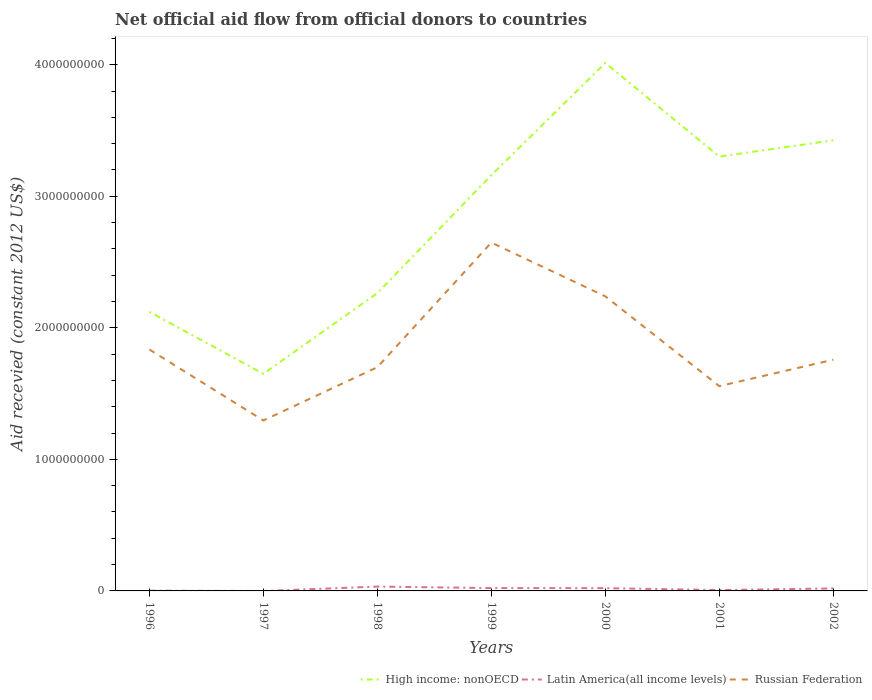Does the line corresponding to Russian Federation intersect with the line corresponding to Latin America(all income levels)?
Offer a very short reply. No. What is the total total aid received in High income: nonOECD in the graph?
Give a very brief answer. -1.30e+09. What is the difference between the highest and the second highest total aid received in Russian Federation?
Offer a terse response. 1.35e+09. How many lines are there?
Ensure brevity in your answer.  3. What is the difference between two consecutive major ticks on the Y-axis?
Make the answer very short. 1.00e+09. Are the values on the major ticks of Y-axis written in scientific E-notation?
Offer a terse response. No. Does the graph contain any zero values?
Make the answer very short. Yes. Does the graph contain grids?
Your answer should be compact. No. Where does the legend appear in the graph?
Offer a very short reply. Bottom right. How are the legend labels stacked?
Provide a short and direct response. Horizontal. What is the title of the graph?
Your answer should be compact. Net official aid flow from official donors to countries. What is the label or title of the Y-axis?
Offer a very short reply. Aid recevied (constant 2012 US$). What is the Aid recevied (constant 2012 US$) in High income: nonOECD in 1996?
Your answer should be compact. 2.12e+09. What is the Aid recevied (constant 2012 US$) of Latin America(all income levels) in 1996?
Your response must be concise. 2.04e+06. What is the Aid recevied (constant 2012 US$) of Russian Federation in 1996?
Give a very brief answer. 1.84e+09. What is the Aid recevied (constant 2012 US$) in High income: nonOECD in 1997?
Make the answer very short. 1.65e+09. What is the Aid recevied (constant 2012 US$) of Russian Federation in 1997?
Offer a very short reply. 1.30e+09. What is the Aid recevied (constant 2012 US$) in High income: nonOECD in 1998?
Provide a succinct answer. 2.26e+09. What is the Aid recevied (constant 2012 US$) in Latin America(all income levels) in 1998?
Ensure brevity in your answer.  3.30e+07. What is the Aid recevied (constant 2012 US$) in Russian Federation in 1998?
Keep it short and to the point. 1.70e+09. What is the Aid recevied (constant 2012 US$) in High income: nonOECD in 1999?
Make the answer very short. 3.16e+09. What is the Aid recevied (constant 2012 US$) in Latin America(all income levels) in 1999?
Offer a terse response. 2.15e+07. What is the Aid recevied (constant 2012 US$) in Russian Federation in 1999?
Your answer should be compact. 2.65e+09. What is the Aid recevied (constant 2012 US$) of High income: nonOECD in 2000?
Make the answer very short. 4.01e+09. What is the Aid recevied (constant 2012 US$) of Latin America(all income levels) in 2000?
Provide a succinct answer. 2.10e+07. What is the Aid recevied (constant 2012 US$) of Russian Federation in 2000?
Provide a short and direct response. 2.24e+09. What is the Aid recevied (constant 2012 US$) in High income: nonOECD in 2001?
Your response must be concise. 3.30e+09. What is the Aid recevied (constant 2012 US$) in Latin America(all income levels) in 2001?
Provide a succinct answer. 6.75e+06. What is the Aid recevied (constant 2012 US$) of Russian Federation in 2001?
Your answer should be very brief. 1.56e+09. What is the Aid recevied (constant 2012 US$) of High income: nonOECD in 2002?
Make the answer very short. 3.43e+09. What is the Aid recevied (constant 2012 US$) of Latin America(all income levels) in 2002?
Your answer should be very brief. 1.90e+07. What is the Aid recevied (constant 2012 US$) in Russian Federation in 2002?
Your answer should be compact. 1.76e+09. Across all years, what is the maximum Aid recevied (constant 2012 US$) in High income: nonOECD?
Keep it short and to the point. 4.01e+09. Across all years, what is the maximum Aid recevied (constant 2012 US$) of Latin America(all income levels)?
Keep it short and to the point. 3.30e+07. Across all years, what is the maximum Aid recevied (constant 2012 US$) of Russian Federation?
Ensure brevity in your answer.  2.65e+09. Across all years, what is the minimum Aid recevied (constant 2012 US$) in High income: nonOECD?
Make the answer very short. 1.65e+09. Across all years, what is the minimum Aid recevied (constant 2012 US$) of Russian Federation?
Offer a terse response. 1.30e+09. What is the total Aid recevied (constant 2012 US$) of High income: nonOECD in the graph?
Make the answer very short. 1.99e+1. What is the total Aid recevied (constant 2012 US$) of Latin America(all income levels) in the graph?
Give a very brief answer. 1.03e+08. What is the total Aid recevied (constant 2012 US$) in Russian Federation in the graph?
Provide a short and direct response. 1.30e+1. What is the difference between the Aid recevied (constant 2012 US$) in High income: nonOECD in 1996 and that in 1997?
Your answer should be compact. 4.71e+08. What is the difference between the Aid recevied (constant 2012 US$) in Russian Federation in 1996 and that in 1997?
Offer a terse response. 5.39e+08. What is the difference between the Aid recevied (constant 2012 US$) of High income: nonOECD in 1996 and that in 1998?
Give a very brief answer. -1.43e+08. What is the difference between the Aid recevied (constant 2012 US$) of Latin America(all income levels) in 1996 and that in 1998?
Keep it short and to the point. -3.10e+07. What is the difference between the Aid recevied (constant 2012 US$) in Russian Federation in 1996 and that in 1998?
Your answer should be very brief. 1.34e+08. What is the difference between the Aid recevied (constant 2012 US$) of High income: nonOECD in 1996 and that in 1999?
Keep it short and to the point. -1.04e+09. What is the difference between the Aid recevied (constant 2012 US$) in Latin America(all income levels) in 1996 and that in 1999?
Keep it short and to the point. -1.95e+07. What is the difference between the Aid recevied (constant 2012 US$) of Russian Federation in 1996 and that in 1999?
Ensure brevity in your answer.  -8.13e+08. What is the difference between the Aid recevied (constant 2012 US$) of High income: nonOECD in 1996 and that in 2000?
Give a very brief answer. -1.89e+09. What is the difference between the Aid recevied (constant 2012 US$) in Latin America(all income levels) in 1996 and that in 2000?
Provide a succinct answer. -1.90e+07. What is the difference between the Aid recevied (constant 2012 US$) of Russian Federation in 1996 and that in 2000?
Provide a succinct answer. -4.04e+08. What is the difference between the Aid recevied (constant 2012 US$) of High income: nonOECD in 1996 and that in 2001?
Your response must be concise. -1.18e+09. What is the difference between the Aid recevied (constant 2012 US$) in Latin America(all income levels) in 1996 and that in 2001?
Give a very brief answer. -4.71e+06. What is the difference between the Aid recevied (constant 2012 US$) of Russian Federation in 1996 and that in 2001?
Your answer should be compact. 2.78e+08. What is the difference between the Aid recevied (constant 2012 US$) of High income: nonOECD in 1996 and that in 2002?
Provide a short and direct response. -1.30e+09. What is the difference between the Aid recevied (constant 2012 US$) in Latin America(all income levels) in 1996 and that in 2002?
Your answer should be compact. -1.70e+07. What is the difference between the Aid recevied (constant 2012 US$) of Russian Federation in 1996 and that in 2002?
Ensure brevity in your answer.  7.76e+07. What is the difference between the Aid recevied (constant 2012 US$) in High income: nonOECD in 1997 and that in 1998?
Offer a terse response. -6.13e+08. What is the difference between the Aid recevied (constant 2012 US$) in Russian Federation in 1997 and that in 1998?
Offer a very short reply. -4.05e+08. What is the difference between the Aid recevied (constant 2012 US$) of High income: nonOECD in 1997 and that in 1999?
Provide a short and direct response. -1.51e+09. What is the difference between the Aid recevied (constant 2012 US$) in Russian Federation in 1997 and that in 1999?
Give a very brief answer. -1.35e+09. What is the difference between the Aid recevied (constant 2012 US$) in High income: nonOECD in 1997 and that in 2000?
Provide a short and direct response. -2.36e+09. What is the difference between the Aid recevied (constant 2012 US$) in Russian Federation in 1997 and that in 2000?
Your answer should be very brief. -9.44e+08. What is the difference between the Aid recevied (constant 2012 US$) of High income: nonOECD in 1997 and that in 2001?
Give a very brief answer. -1.65e+09. What is the difference between the Aid recevied (constant 2012 US$) of Russian Federation in 1997 and that in 2001?
Provide a succinct answer. -2.61e+08. What is the difference between the Aid recevied (constant 2012 US$) in High income: nonOECD in 1997 and that in 2002?
Your answer should be compact. -1.78e+09. What is the difference between the Aid recevied (constant 2012 US$) in Russian Federation in 1997 and that in 2002?
Give a very brief answer. -4.62e+08. What is the difference between the Aid recevied (constant 2012 US$) of High income: nonOECD in 1998 and that in 1999?
Give a very brief answer. -8.97e+08. What is the difference between the Aid recevied (constant 2012 US$) in Latin America(all income levels) in 1998 and that in 1999?
Make the answer very short. 1.15e+07. What is the difference between the Aid recevied (constant 2012 US$) in Russian Federation in 1998 and that in 1999?
Ensure brevity in your answer.  -9.47e+08. What is the difference between the Aid recevied (constant 2012 US$) in High income: nonOECD in 1998 and that in 2000?
Make the answer very short. -1.75e+09. What is the difference between the Aid recevied (constant 2012 US$) in Latin America(all income levels) in 1998 and that in 2000?
Ensure brevity in your answer.  1.20e+07. What is the difference between the Aid recevied (constant 2012 US$) of Russian Federation in 1998 and that in 2000?
Make the answer very short. -5.38e+08. What is the difference between the Aid recevied (constant 2012 US$) of High income: nonOECD in 1998 and that in 2001?
Your answer should be very brief. -1.04e+09. What is the difference between the Aid recevied (constant 2012 US$) of Latin America(all income levels) in 1998 and that in 2001?
Your answer should be compact. 2.63e+07. What is the difference between the Aid recevied (constant 2012 US$) of Russian Federation in 1998 and that in 2001?
Provide a succinct answer. 1.44e+08. What is the difference between the Aid recevied (constant 2012 US$) of High income: nonOECD in 1998 and that in 2002?
Give a very brief answer. -1.16e+09. What is the difference between the Aid recevied (constant 2012 US$) in Latin America(all income levels) in 1998 and that in 2002?
Make the answer very short. 1.40e+07. What is the difference between the Aid recevied (constant 2012 US$) in Russian Federation in 1998 and that in 2002?
Make the answer very short. -5.68e+07. What is the difference between the Aid recevied (constant 2012 US$) of High income: nonOECD in 1999 and that in 2000?
Ensure brevity in your answer.  -8.53e+08. What is the difference between the Aid recevied (constant 2012 US$) in Russian Federation in 1999 and that in 2000?
Keep it short and to the point. 4.09e+08. What is the difference between the Aid recevied (constant 2012 US$) of High income: nonOECD in 1999 and that in 2001?
Ensure brevity in your answer.  -1.41e+08. What is the difference between the Aid recevied (constant 2012 US$) of Latin America(all income levels) in 1999 and that in 2001?
Offer a very short reply. 1.48e+07. What is the difference between the Aid recevied (constant 2012 US$) of Russian Federation in 1999 and that in 2001?
Ensure brevity in your answer.  1.09e+09. What is the difference between the Aid recevied (constant 2012 US$) in High income: nonOECD in 1999 and that in 2002?
Your response must be concise. -2.65e+08. What is the difference between the Aid recevied (constant 2012 US$) in Latin America(all income levels) in 1999 and that in 2002?
Your answer should be very brief. 2.47e+06. What is the difference between the Aid recevied (constant 2012 US$) of Russian Federation in 1999 and that in 2002?
Offer a terse response. 8.90e+08. What is the difference between the Aid recevied (constant 2012 US$) in High income: nonOECD in 2000 and that in 2001?
Ensure brevity in your answer.  7.12e+08. What is the difference between the Aid recevied (constant 2012 US$) of Latin America(all income levels) in 2000 and that in 2001?
Offer a very short reply. 1.43e+07. What is the difference between the Aid recevied (constant 2012 US$) of Russian Federation in 2000 and that in 2001?
Your answer should be very brief. 6.83e+08. What is the difference between the Aid recevied (constant 2012 US$) in High income: nonOECD in 2000 and that in 2002?
Give a very brief answer. 5.88e+08. What is the difference between the Aid recevied (constant 2012 US$) in Latin America(all income levels) in 2000 and that in 2002?
Give a very brief answer. 2.02e+06. What is the difference between the Aid recevied (constant 2012 US$) of Russian Federation in 2000 and that in 2002?
Make the answer very short. 4.82e+08. What is the difference between the Aid recevied (constant 2012 US$) in High income: nonOECD in 2001 and that in 2002?
Your answer should be compact. -1.24e+08. What is the difference between the Aid recevied (constant 2012 US$) in Latin America(all income levels) in 2001 and that in 2002?
Offer a very short reply. -1.23e+07. What is the difference between the Aid recevied (constant 2012 US$) of Russian Federation in 2001 and that in 2002?
Make the answer very short. -2.01e+08. What is the difference between the Aid recevied (constant 2012 US$) of High income: nonOECD in 1996 and the Aid recevied (constant 2012 US$) of Russian Federation in 1997?
Your response must be concise. 8.26e+08. What is the difference between the Aid recevied (constant 2012 US$) of Latin America(all income levels) in 1996 and the Aid recevied (constant 2012 US$) of Russian Federation in 1997?
Give a very brief answer. -1.29e+09. What is the difference between the Aid recevied (constant 2012 US$) of High income: nonOECD in 1996 and the Aid recevied (constant 2012 US$) of Latin America(all income levels) in 1998?
Give a very brief answer. 2.09e+09. What is the difference between the Aid recevied (constant 2012 US$) of High income: nonOECD in 1996 and the Aid recevied (constant 2012 US$) of Russian Federation in 1998?
Provide a short and direct response. 4.21e+08. What is the difference between the Aid recevied (constant 2012 US$) in Latin America(all income levels) in 1996 and the Aid recevied (constant 2012 US$) in Russian Federation in 1998?
Your answer should be very brief. -1.70e+09. What is the difference between the Aid recevied (constant 2012 US$) of High income: nonOECD in 1996 and the Aid recevied (constant 2012 US$) of Latin America(all income levels) in 1999?
Provide a succinct answer. 2.10e+09. What is the difference between the Aid recevied (constant 2012 US$) of High income: nonOECD in 1996 and the Aid recevied (constant 2012 US$) of Russian Federation in 1999?
Your answer should be very brief. -5.27e+08. What is the difference between the Aid recevied (constant 2012 US$) of Latin America(all income levels) in 1996 and the Aid recevied (constant 2012 US$) of Russian Federation in 1999?
Give a very brief answer. -2.65e+09. What is the difference between the Aid recevied (constant 2012 US$) in High income: nonOECD in 1996 and the Aid recevied (constant 2012 US$) in Latin America(all income levels) in 2000?
Your answer should be very brief. 2.10e+09. What is the difference between the Aid recevied (constant 2012 US$) in High income: nonOECD in 1996 and the Aid recevied (constant 2012 US$) in Russian Federation in 2000?
Provide a short and direct response. -1.18e+08. What is the difference between the Aid recevied (constant 2012 US$) in Latin America(all income levels) in 1996 and the Aid recevied (constant 2012 US$) in Russian Federation in 2000?
Keep it short and to the point. -2.24e+09. What is the difference between the Aid recevied (constant 2012 US$) of High income: nonOECD in 1996 and the Aid recevied (constant 2012 US$) of Latin America(all income levels) in 2001?
Provide a succinct answer. 2.11e+09. What is the difference between the Aid recevied (constant 2012 US$) in High income: nonOECD in 1996 and the Aid recevied (constant 2012 US$) in Russian Federation in 2001?
Keep it short and to the point. 5.65e+08. What is the difference between the Aid recevied (constant 2012 US$) in Latin America(all income levels) in 1996 and the Aid recevied (constant 2012 US$) in Russian Federation in 2001?
Your answer should be compact. -1.55e+09. What is the difference between the Aid recevied (constant 2012 US$) of High income: nonOECD in 1996 and the Aid recevied (constant 2012 US$) of Latin America(all income levels) in 2002?
Keep it short and to the point. 2.10e+09. What is the difference between the Aid recevied (constant 2012 US$) in High income: nonOECD in 1996 and the Aid recevied (constant 2012 US$) in Russian Federation in 2002?
Make the answer very short. 3.64e+08. What is the difference between the Aid recevied (constant 2012 US$) of Latin America(all income levels) in 1996 and the Aid recevied (constant 2012 US$) of Russian Federation in 2002?
Your response must be concise. -1.76e+09. What is the difference between the Aid recevied (constant 2012 US$) in High income: nonOECD in 1997 and the Aid recevied (constant 2012 US$) in Latin America(all income levels) in 1998?
Give a very brief answer. 1.62e+09. What is the difference between the Aid recevied (constant 2012 US$) of High income: nonOECD in 1997 and the Aid recevied (constant 2012 US$) of Russian Federation in 1998?
Provide a short and direct response. -5.02e+07. What is the difference between the Aid recevied (constant 2012 US$) of High income: nonOECD in 1997 and the Aid recevied (constant 2012 US$) of Latin America(all income levels) in 1999?
Keep it short and to the point. 1.63e+09. What is the difference between the Aid recevied (constant 2012 US$) in High income: nonOECD in 1997 and the Aid recevied (constant 2012 US$) in Russian Federation in 1999?
Offer a terse response. -9.97e+08. What is the difference between the Aid recevied (constant 2012 US$) in High income: nonOECD in 1997 and the Aid recevied (constant 2012 US$) in Latin America(all income levels) in 2000?
Keep it short and to the point. 1.63e+09. What is the difference between the Aid recevied (constant 2012 US$) of High income: nonOECD in 1997 and the Aid recevied (constant 2012 US$) of Russian Federation in 2000?
Your answer should be very brief. -5.89e+08. What is the difference between the Aid recevied (constant 2012 US$) in High income: nonOECD in 1997 and the Aid recevied (constant 2012 US$) in Latin America(all income levels) in 2001?
Your answer should be very brief. 1.64e+09. What is the difference between the Aid recevied (constant 2012 US$) in High income: nonOECD in 1997 and the Aid recevied (constant 2012 US$) in Russian Federation in 2001?
Provide a short and direct response. 9.38e+07. What is the difference between the Aid recevied (constant 2012 US$) of High income: nonOECD in 1997 and the Aid recevied (constant 2012 US$) of Latin America(all income levels) in 2002?
Offer a terse response. 1.63e+09. What is the difference between the Aid recevied (constant 2012 US$) in High income: nonOECD in 1997 and the Aid recevied (constant 2012 US$) in Russian Federation in 2002?
Provide a succinct answer. -1.07e+08. What is the difference between the Aid recevied (constant 2012 US$) of High income: nonOECD in 1998 and the Aid recevied (constant 2012 US$) of Latin America(all income levels) in 1999?
Offer a terse response. 2.24e+09. What is the difference between the Aid recevied (constant 2012 US$) of High income: nonOECD in 1998 and the Aid recevied (constant 2012 US$) of Russian Federation in 1999?
Give a very brief answer. -3.84e+08. What is the difference between the Aid recevied (constant 2012 US$) in Latin America(all income levels) in 1998 and the Aid recevied (constant 2012 US$) in Russian Federation in 1999?
Keep it short and to the point. -2.61e+09. What is the difference between the Aid recevied (constant 2012 US$) of High income: nonOECD in 1998 and the Aid recevied (constant 2012 US$) of Latin America(all income levels) in 2000?
Keep it short and to the point. 2.24e+09. What is the difference between the Aid recevied (constant 2012 US$) in High income: nonOECD in 1998 and the Aid recevied (constant 2012 US$) in Russian Federation in 2000?
Provide a succinct answer. 2.47e+07. What is the difference between the Aid recevied (constant 2012 US$) in Latin America(all income levels) in 1998 and the Aid recevied (constant 2012 US$) in Russian Federation in 2000?
Ensure brevity in your answer.  -2.21e+09. What is the difference between the Aid recevied (constant 2012 US$) in High income: nonOECD in 1998 and the Aid recevied (constant 2012 US$) in Latin America(all income levels) in 2001?
Provide a succinct answer. 2.26e+09. What is the difference between the Aid recevied (constant 2012 US$) in High income: nonOECD in 1998 and the Aid recevied (constant 2012 US$) in Russian Federation in 2001?
Your answer should be very brief. 7.07e+08. What is the difference between the Aid recevied (constant 2012 US$) in Latin America(all income levels) in 1998 and the Aid recevied (constant 2012 US$) in Russian Federation in 2001?
Your response must be concise. -1.52e+09. What is the difference between the Aid recevied (constant 2012 US$) of High income: nonOECD in 1998 and the Aid recevied (constant 2012 US$) of Latin America(all income levels) in 2002?
Keep it short and to the point. 2.24e+09. What is the difference between the Aid recevied (constant 2012 US$) in High income: nonOECD in 1998 and the Aid recevied (constant 2012 US$) in Russian Federation in 2002?
Your answer should be compact. 5.06e+08. What is the difference between the Aid recevied (constant 2012 US$) of Latin America(all income levels) in 1998 and the Aid recevied (constant 2012 US$) of Russian Federation in 2002?
Provide a short and direct response. -1.72e+09. What is the difference between the Aid recevied (constant 2012 US$) in High income: nonOECD in 1999 and the Aid recevied (constant 2012 US$) in Latin America(all income levels) in 2000?
Your answer should be very brief. 3.14e+09. What is the difference between the Aid recevied (constant 2012 US$) of High income: nonOECD in 1999 and the Aid recevied (constant 2012 US$) of Russian Federation in 2000?
Provide a short and direct response. 9.21e+08. What is the difference between the Aid recevied (constant 2012 US$) in Latin America(all income levels) in 1999 and the Aid recevied (constant 2012 US$) in Russian Federation in 2000?
Ensure brevity in your answer.  -2.22e+09. What is the difference between the Aid recevied (constant 2012 US$) in High income: nonOECD in 1999 and the Aid recevied (constant 2012 US$) in Latin America(all income levels) in 2001?
Give a very brief answer. 3.15e+09. What is the difference between the Aid recevied (constant 2012 US$) of High income: nonOECD in 1999 and the Aid recevied (constant 2012 US$) of Russian Federation in 2001?
Provide a short and direct response. 1.60e+09. What is the difference between the Aid recevied (constant 2012 US$) of Latin America(all income levels) in 1999 and the Aid recevied (constant 2012 US$) of Russian Federation in 2001?
Keep it short and to the point. -1.54e+09. What is the difference between the Aid recevied (constant 2012 US$) in High income: nonOECD in 1999 and the Aid recevied (constant 2012 US$) in Latin America(all income levels) in 2002?
Your response must be concise. 3.14e+09. What is the difference between the Aid recevied (constant 2012 US$) of High income: nonOECD in 1999 and the Aid recevied (constant 2012 US$) of Russian Federation in 2002?
Your answer should be very brief. 1.40e+09. What is the difference between the Aid recevied (constant 2012 US$) of Latin America(all income levels) in 1999 and the Aid recevied (constant 2012 US$) of Russian Federation in 2002?
Ensure brevity in your answer.  -1.74e+09. What is the difference between the Aid recevied (constant 2012 US$) of High income: nonOECD in 2000 and the Aid recevied (constant 2012 US$) of Latin America(all income levels) in 2001?
Ensure brevity in your answer.  4.01e+09. What is the difference between the Aid recevied (constant 2012 US$) of High income: nonOECD in 2000 and the Aid recevied (constant 2012 US$) of Russian Federation in 2001?
Offer a very short reply. 2.46e+09. What is the difference between the Aid recevied (constant 2012 US$) in Latin America(all income levels) in 2000 and the Aid recevied (constant 2012 US$) in Russian Federation in 2001?
Provide a succinct answer. -1.54e+09. What is the difference between the Aid recevied (constant 2012 US$) of High income: nonOECD in 2000 and the Aid recevied (constant 2012 US$) of Latin America(all income levels) in 2002?
Ensure brevity in your answer.  3.99e+09. What is the difference between the Aid recevied (constant 2012 US$) of High income: nonOECD in 2000 and the Aid recevied (constant 2012 US$) of Russian Federation in 2002?
Keep it short and to the point. 2.26e+09. What is the difference between the Aid recevied (constant 2012 US$) in Latin America(all income levels) in 2000 and the Aid recevied (constant 2012 US$) in Russian Federation in 2002?
Keep it short and to the point. -1.74e+09. What is the difference between the Aid recevied (constant 2012 US$) in High income: nonOECD in 2001 and the Aid recevied (constant 2012 US$) in Latin America(all income levels) in 2002?
Your response must be concise. 3.28e+09. What is the difference between the Aid recevied (constant 2012 US$) in High income: nonOECD in 2001 and the Aid recevied (constant 2012 US$) in Russian Federation in 2002?
Make the answer very short. 1.54e+09. What is the difference between the Aid recevied (constant 2012 US$) in Latin America(all income levels) in 2001 and the Aid recevied (constant 2012 US$) in Russian Federation in 2002?
Offer a terse response. -1.75e+09. What is the average Aid recevied (constant 2012 US$) of High income: nonOECD per year?
Offer a terse response. 2.85e+09. What is the average Aid recevied (constant 2012 US$) of Latin America(all income levels) per year?
Provide a succinct answer. 1.48e+07. What is the average Aid recevied (constant 2012 US$) of Russian Federation per year?
Offer a very short reply. 1.86e+09. In the year 1996, what is the difference between the Aid recevied (constant 2012 US$) in High income: nonOECD and Aid recevied (constant 2012 US$) in Latin America(all income levels)?
Offer a terse response. 2.12e+09. In the year 1996, what is the difference between the Aid recevied (constant 2012 US$) in High income: nonOECD and Aid recevied (constant 2012 US$) in Russian Federation?
Your answer should be compact. 2.86e+08. In the year 1996, what is the difference between the Aid recevied (constant 2012 US$) in Latin America(all income levels) and Aid recevied (constant 2012 US$) in Russian Federation?
Your answer should be very brief. -1.83e+09. In the year 1997, what is the difference between the Aid recevied (constant 2012 US$) in High income: nonOECD and Aid recevied (constant 2012 US$) in Russian Federation?
Ensure brevity in your answer.  3.55e+08. In the year 1998, what is the difference between the Aid recevied (constant 2012 US$) of High income: nonOECD and Aid recevied (constant 2012 US$) of Latin America(all income levels)?
Give a very brief answer. 2.23e+09. In the year 1998, what is the difference between the Aid recevied (constant 2012 US$) of High income: nonOECD and Aid recevied (constant 2012 US$) of Russian Federation?
Offer a terse response. 5.63e+08. In the year 1998, what is the difference between the Aid recevied (constant 2012 US$) of Latin America(all income levels) and Aid recevied (constant 2012 US$) of Russian Federation?
Your response must be concise. -1.67e+09. In the year 1999, what is the difference between the Aid recevied (constant 2012 US$) of High income: nonOECD and Aid recevied (constant 2012 US$) of Latin America(all income levels)?
Provide a succinct answer. 3.14e+09. In the year 1999, what is the difference between the Aid recevied (constant 2012 US$) in High income: nonOECD and Aid recevied (constant 2012 US$) in Russian Federation?
Provide a short and direct response. 5.13e+08. In the year 1999, what is the difference between the Aid recevied (constant 2012 US$) of Latin America(all income levels) and Aid recevied (constant 2012 US$) of Russian Federation?
Give a very brief answer. -2.63e+09. In the year 2000, what is the difference between the Aid recevied (constant 2012 US$) of High income: nonOECD and Aid recevied (constant 2012 US$) of Latin America(all income levels)?
Your answer should be very brief. 3.99e+09. In the year 2000, what is the difference between the Aid recevied (constant 2012 US$) of High income: nonOECD and Aid recevied (constant 2012 US$) of Russian Federation?
Provide a succinct answer. 1.77e+09. In the year 2000, what is the difference between the Aid recevied (constant 2012 US$) of Latin America(all income levels) and Aid recevied (constant 2012 US$) of Russian Federation?
Your answer should be compact. -2.22e+09. In the year 2001, what is the difference between the Aid recevied (constant 2012 US$) of High income: nonOECD and Aid recevied (constant 2012 US$) of Latin America(all income levels)?
Offer a very short reply. 3.30e+09. In the year 2001, what is the difference between the Aid recevied (constant 2012 US$) of High income: nonOECD and Aid recevied (constant 2012 US$) of Russian Federation?
Your answer should be compact. 1.75e+09. In the year 2001, what is the difference between the Aid recevied (constant 2012 US$) in Latin America(all income levels) and Aid recevied (constant 2012 US$) in Russian Federation?
Your answer should be very brief. -1.55e+09. In the year 2002, what is the difference between the Aid recevied (constant 2012 US$) in High income: nonOECD and Aid recevied (constant 2012 US$) in Latin America(all income levels)?
Your answer should be very brief. 3.41e+09. In the year 2002, what is the difference between the Aid recevied (constant 2012 US$) in High income: nonOECD and Aid recevied (constant 2012 US$) in Russian Federation?
Offer a very short reply. 1.67e+09. In the year 2002, what is the difference between the Aid recevied (constant 2012 US$) of Latin America(all income levels) and Aid recevied (constant 2012 US$) of Russian Federation?
Make the answer very short. -1.74e+09. What is the ratio of the Aid recevied (constant 2012 US$) in High income: nonOECD in 1996 to that in 1997?
Offer a terse response. 1.29. What is the ratio of the Aid recevied (constant 2012 US$) in Russian Federation in 1996 to that in 1997?
Offer a terse response. 1.42. What is the ratio of the Aid recevied (constant 2012 US$) in High income: nonOECD in 1996 to that in 1998?
Your response must be concise. 0.94. What is the ratio of the Aid recevied (constant 2012 US$) in Latin America(all income levels) in 1996 to that in 1998?
Offer a very short reply. 0.06. What is the ratio of the Aid recevied (constant 2012 US$) of Russian Federation in 1996 to that in 1998?
Keep it short and to the point. 1.08. What is the ratio of the Aid recevied (constant 2012 US$) of High income: nonOECD in 1996 to that in 1999?
Offer a terse response. 0.67. What is the ratio of the Aid recevied (constant 2012 US$) in Latin America(all income levels) in 1996 to that in 1999?
Provide a short and direct response. 0.09. What is the ratio of the Aid recevied (constant 2012 US$) of Russian Federation in 1996 to that in 1999?
Ensure brevity in your answer.  0.69. What is the ratio of the Aid recevied (constant 2012 US$) of High income: nonOECD in 1996 to that in 2000?
Offer a terse response. 0.53. What is the ratio of the Aid recevied (constant 2012 US$) of Latin America(all income levels) in 1996 to that in 2000?
Keep it short and to the point. 0.1. What is the ratio of the Aid recevied (constant 2012 US$) in Russian Federation in 1996 to that in 2000?
Keep it short and to the point. 0.82. What is the ratio of the Aid recevied (constant 2012 US$) in High income: nonOECD in 1996 to that in 2001?
Ensure brevity in your answer.  0.64. What is the ratio of the Aid recevied (constant 2012 US$) of Latin America(all income levels) in 1996 to that in 2001?
Ensure brevity in your answer.  0.3. What is the ratio of the Aid recevied (constant 2012 US$) in Russian Federation in 1996 to that in 2001?
Keep it short and to the point. 1.18. What is the ratio of the Aid recevied (constant 2012 US$) in High income: nonOECD in 1996 to that in 2002?
Ensure brevity in your answer.  0.62. What is the ratio of the Aid recevied (constant 2012 US$) of Latin America(all income levels) in 1996 to that in 2002?
Provide a short and direct response. 0.11. What is the ratio of the Aid recevied (constant 2012 US$) of Russian Federation in 1996 to that in 2002?
Your response must be concise. 1.04. What is the ratio of the Aid recevied (constant 2012 US$) in High income: nonOECD in 1997 to that in 1998?
Keep it short and to the point. 0.73. What is the ratio of the Aid recevied (constant 2012 US$) in Russian Federation in 1997 to that in 1998?
Make the answer very short. 0.76. What is the ratio of the Aid recevied (constant 2012 US$) in High income: nonOECD in 1997 to that in 1999?
Provide a succinct answer. 0.52. What is the ratio of the Aid recevied (constant 2012 US$) in Russian Federation in 1997 to that in 1999?
Provide a short and direct response. 0.49. What is the ratio of the Aid recevied (constant 2012 US$) of High income: nonOECD in 1997 to that in 2000?
Keep it short and to the point. 0.41. What is the ratio of the Aid recevied (constant 2012 US$) of Russian Federation in 1997 to that in 2000?
Provide a short and direct response. 0.58. What is the ratio of the Aid recevied (constant 2012 US$) in High income: nonOECD in 1997 to that in 2001?
Give a very brief answer. 0.5. What is the ratio of the Aid recevied (constant 2012 US$) in Russian Federation in 1997 to that in 2001?
Your response must be concise. 0.83. What is the ratio of the Aid recevied (constant 2012 US$) of High income: nonOECD in 1997 to that in 2002?
Offer a terse response. 0.48. What is the ratio of the Aid recevied (constant 2012 US$) in Russian Federation in 1997 to that in 2002?
Offer a very short reply. 0.74. What is the ratio of the Aid recevied (constant 2012 US$) of High income: nonOECD in 1998 to that in 1999?
Your answer should be very brief. 0.72. What is the ratio of the Aid recevied (constant 2012 US$) of Latin America(all income levels) in 1998 to that in 1999?
Your answer should be compact. 1.54. What is the ratio of the Aid recevied (constant 2012 US$) in Russian Federation in 1998 to that in 1999?
Provide a succinct answer. 0.64. What is the ratio of the Aid recevied (constant 2012 US$) in High income: nonOECD in 1998 to that in 2000?
Your response must be concise. 0.56. What is the ratio of the Aid recevied (constant 2012 US$) in Latin America(all income levels) in 1998 to that in 2000?
Provide a short and direct response. 1.57. What is the ratio of the Aid recevied (constant 2012 US$) in Russian Federation in 1998 to that in 2000?
Keep it short and to the point. 0.76. What is the ratio of the Aid recevied (constant 2012 US$) of High income: nonOECD in 1998 to that in 2001?
Offer a very short reply. 0.69. What is the ratio of the Aid recevied (constant 2012 US$) in Latin America(all income levels) in 1998 to that in 2001?
Make the answer very short. 4.89. What is the ratio of the Aid recevied (constant 2012 US$) in Russian Federation in 1998 to that in 2001?
Keep it short and to the point. 1.09. What is the ratio of the Aid recevied (constant 2012 US$) in High income: nonOECD in 1998 to that in 2002?
Your response must be concise. 0.66. What is the ratio of the Aid recevied (constant 2012 US$) in Latin America(all income levels) in 1998 to that in 2002?
Keep it short and to the point. 1.73. What is the ratio of the Aid recevied (constant 2012 US$) in Russian Federation in 1998 to that in 2002?
Provide a short and direct response. 0.97. What is the ratio of the Aid recevied (constant 2012 US$) in High income: nonOECD in 1999 to that in 2000?
Provide a short and direct response. 0.79. What is the ratio of the Aid recevied (constant 2012 US$) of Latin America(all income levels) in 1999 to that in 2000?
Provide a short and direct response. 1.02. What is the ratio of the Aid recevied (constant 2012 US$) of Russian Federation in 1999 to that in 2000?
Provide a short and direct response. 1.18. What is the ratio of the Aid recevied (constant 2012 US$) of High income: nonOECD in 1999 to that in 2001?
Your answer should be very brief. 0.96. What is the ratio of the Aid recevied (constant 2012 US$) of Latin America(all income levels) in 1999 to that in 2001?
Offer a terse response. 3.19. What is the ratio of the Aid recevied (constant 2012 US$) in Russian Federation in 1999 to that in 2001?
Provide a succinct answer. 1.7. What is the ratio of the Aid recevied (constant 2012 US$) of High income: nonOECD in 1999 to that in 2002?
Provide a short and direct response. 0.92. What is the ratio of the Aid recevied (constant 2012 US$) in Latin America(all income levels) in 1999 to that in 2002?
Keep it short and to the point. 1.13. What is the ratio of the Aid recevied (constant 2012 US$) in Russian Federation in 1999 to that in 2002?
Provide a succinct answer. 1.51. What is the ratio of the Aid recevied (constant 2012 US$) of High income: nonOECD in 2000 to that in 2001?
Keep it short and to the point. 1.22. What is the ratio of the Aid recevied (constant 2012 US$) of Latin America(all income levels) in 2000 to that in 2001?
Provide a short and direct response. 3.12. What is the ratio of the Aid recevied (constant 2012 US$) in Russian Federation in 2000 to that in 2001?
Offer a very short reply. 1.44. What is the ratio of the Aid recevied (constant 2012 US$) of High income: nonOECD in 2000 to that in 2002?
Your answer should be very brief. 1.17. What is the ratio of the Aid recevied (constant 2012 US$) in Latin America(all income levels) in 2000 to that in 2002?
Offer a terse response. 1.11. What is the ratio of the Aid recevied (constant 2012 US$) of Russian Federation in 2000 to that in 2002?
Provide a succinct answer. 1.27. What is the ratio of the Aid recevied (constant 2012 US$) of High income: nonOECD in 2001 to that in 2002?
Provide a succinct answer. 0.96. What is the ratio of the Aid recevied (constant 2012 US$) in Latin America(all income levels) in 2001 to that in 2002?
Offer a terse response. 0.35. What is the ratio of the Aid recevied (constant 2012 US$) in Russian Federation in 2001 to that in 2002?
Your answer should be compact. 0.89. What is the difference between the highest and the second highest Aid recevied (constant 2012 US$) in High income: nonOECD?
Your answer should be very brief. 5.88e+08. What is the difference between the highest and the second highest Aid recevied (constant 2012 US$) of Latin America(all income levels)?
Offer a very short reply. 1.15e+07. What is the difference between the highest and the second highest Aid recevied (constant 2012 US$) in Russian Federation?
Give a very brief answer. 4.09e+08. What is the difference between the highest and the lowest Aid recevied (constant 2012 US$) in High income: nonOECD?
Your response must be concise. 2.36e+09. What is the difference between the highest and the lowest Aid recevied (constant 2012 US$) in Latin America(all income levels)?
Offer a very short reply. 3.30e+07. What is the difference between the highest and the lowest Aid recevied (constant 2012 US$) in Russian Federation?
Make the answer very short. 1.35e+09. 